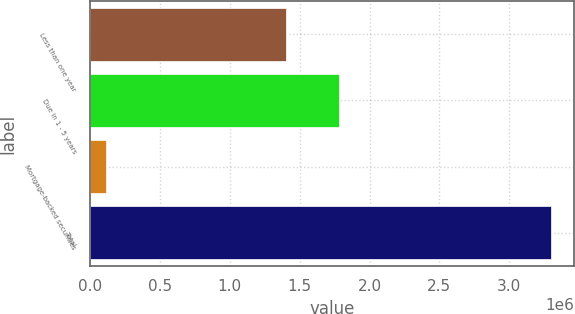Convert chart. <chart><loc_0><loc_0><loc_500><loc_500><bar_chart><fcel>Less than one year<fcel>Due in 1 - 5 years<fcel>Mortgage-backed securities<fcel>Total<nl><fcel>1.3993e+06<fcel>1.7831e+06<fcel>114856<fcel>3.29726e+06<nl></chart> 